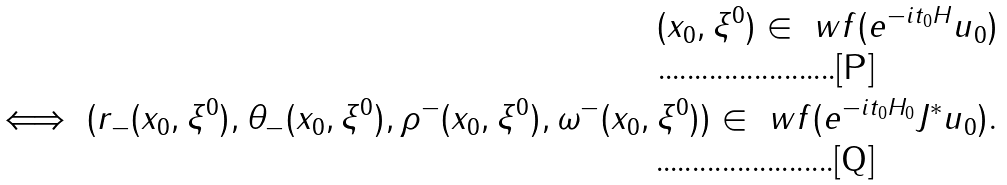<formula> <loc_0><loc_0><loc_500><loc_500>( x _ { 0 } , \xi ^ { 0 } ) \in \ w f ( e ^ { - i t _ { 0 } H } u _ { 0 } ) \\ \iff ( r _ { - } ( x _ { 0 } , \xi ^ { 0 } ) , \theta _ { - } ( x _ { 0 } , \xi ^ { 0 } ) , \rho ^ { - } ( x _ { 0 } , \xi ^ { 0 } ) , \omega ^ { - } ( x _ { 0 } , \xi ^ { 0 } ) ) \in \ w f ( e ^ { - i t _ { 0 } H _ { 0 } } J ^ { * } u _ { 0 } ) .</formula> 